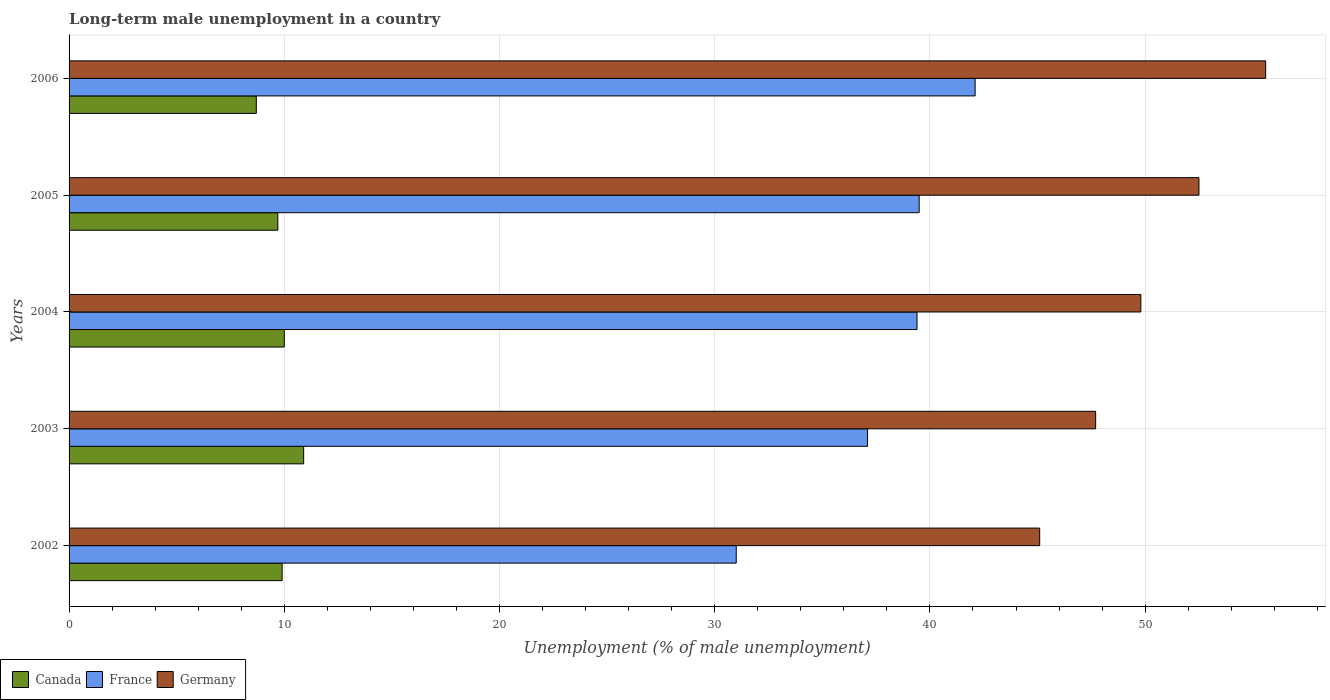How many different coloured bars are there?
Offer a terse response. 3. Are the number of bars per tick equal to the number of legend labels?
Give a very brief answer. Yes. Are the number of bars on each tick of the Y-axis equal?
Offer a very short reply. Yes. What is the percentage of long-term unemployed male population in Canada in 2006?
Offer a terse response. 8.7. Across all years, what is the maximum percentage of long-term unemployed male population in France?
Your response must be concise. 42.1. Across all years, what is the minimum percentage of long-term unemployed male population in Germany?
Offer a terse response. 45.1. In which year was the percentage of long-term unemployed male population in France maximum?
Your answer should be very brief. 2006. In which year was the percentage of long-term unemployed male population in Canada minimum?
Provide a succinct answer. 2006. What is the total percentage of long-term unemployed male population in Canada in the graph?
Offer a terse response. 49.2. What is the difference between the percentage of long-term unemployed male population in Germany in 2002 and that in 2004?
Your answer should be very brief. -4.7. What is the difference between the percentage of long-term unemployed male population in Canada in 2004 and the percentage of long-term unemployed male population in France in 2005?
Offer a very short reply. -29.5. What is the average percentage of long-term unemployed male population in France per year?
Offer a very short reply. 37.82. In the year 2002, what is the difference between the percentage of long-term unemployed male population in France and percentage of long-term unemployed male population in Germany?
Your answer should be very brief. -14.1. What is the ratio of the percentage of long-term unemployed male population in Germany in 2002 to that in 2006?
Provide a succinct answer. 0.81. Is the percentage of long-term unemployed male population in France in 2005 less than that in 2006?
Keep it short and to the point. Yes. Is the difference between the percentage of long-term unemployed male population in France in 2004 and 2005 greater than the difference between the percentage of long-term unemployed male population in Germany in 2004 and 2005?
Keep it short and to the point. Yes. What is the difference between the highest and the second highest percentage of long-term unemployed male population in Germany?
Your answer should be compact. 3.1. What is the difference between the highest and the lowest percentage of long-term unemployed male population in Germany?
Offer a terse response. 10.5. In how many years, is the percentage of long-term unemployed male population in Germany greater than the average percentage of long-term unemployed male population in Germany taken over all years?
Your response must be concise. 2. What does the 1st bar from the bottom in 2002 represents?
Your response must be concise. Canada. How many bars are there?
Make the answer very short. 15. How many years are there in the graph?
Your answer should be compact. 5. What is the difference between two consecutive major ticks on the X-axis?
Your answer should be very brief. 10. Where does the legend appear in the graph?
Give a very brief answer. Bottom left. How many legend labels are there?
Provide a short and direct response. 3. How are the legend labels stacked?
Offer a terse response. Horizontal. What is the title of the graph?
Provide a succinct answer. Long-term male unemployment in a country. What is the label or title of the X-axis?
Offer a very short reply. Unemployment (% of male unemployment). What is the Unemployment (% of male unemployment) in Canada in 2002?
Provide a short and direct response. 9.9. What is the Unemployment (% of male unemployment) in Germany in 2002?
Your answer should be very brief. 45.1. What is the Unemployment (% of male unemployment) of Canada in 2003?
Make the answer very short. 10.9. What is the Unemployment (% of male unemployment) in France in 2003?
Give a very brief answer. 37.1. What is the Unemployment (% of male unemployment) in Germany in 2003?
Ensure brevity in your answer.  47.7. What is the Unemployment (% of male unemployment) of Canada in 2004?
Offer a very short reply. 10. What is the Unemployment (% of male unemployment) of France in 2004?
Your answer should be very brief. 39.4. What is the Unemployment (% of male unemployment) in Germany in 2004?
Give a very brief answer. 49.8. What is the Unemployment (% of male unemployment) of Canada in 2005?
Provide a succinct answer. 9.7. What is the Unemployment (% of male unemployment) in France in 2005?
Your answer should be very brief. 39.5. What is the Unemployment (% of male unemployment) in Germany in 2005?
Ensure brevity in your answer.  52.5. What is the Unemployment (% of male unemployment) of Canada in 2006?
Make the answer very short. 8.7. What is the Unemployment (% of male unemployment) of France in 2006?
Make the answer very short. 42.1. What is the Unemployment (% of male unemployment) in Germany in 2006?
Offer a terse response. 55.6. Across all years, what is the maximum Unemployment (% of male unemployment) of Canada?
Keep it short and to the point. 10.9. Across all years, what is the maximum Unemployment (% of male unemployment) in France?
Make the answer very short. 42.1. Across all years, what is the maximum Unemployment (% of male unemployment) of Germany?
Offer a very short reply. 55.6. Across all years, what is the minimum Unemployment (% of male unemployment) in Canada?
Offer a very short reply. 8.7. Across all years, what is the minimum Unemployment (% of male unemployment) of France?
Your answer should be compact. 31. Across all years, what is the minimum Unemployment (% of male unemployment) in Germany?
Your answer should be very brief. 45.1. What is the total Unemployment (% of male unemployment) in Canada in the graph?
Your answer should be compact. 49.2. What is the total Unemployment (% of male unemployment) in France in the graph?
Your answer should be very brief. 189.1. What is the total Unemployment (% of male unemployment) of Germany in the graph?
Keep it short and to the point. 250.7. What is the difference between the Unemployment (% of male unemployment) of Canada in 2002 and that in 2003?
Your answer should be compact. -1. What is the difference between the Unemployment (% of male unemployment) in France in 2002 and that in 2003?
Your answer should be very brief. -6.1. What is the difference between the Unemployment (% of male unemployment) in Germany in 2002 and that in 2003?
Offer a terse response. -2.6. What is the difference between the Unemployment (% of male unemployment) in Germany in 2002 and that in 2004?
Offer a terse response. -4.7. What is the difference between the Unemployment (% of male unemployment) of France in 2002 and that in 2005?
Provide a succinct answer. -8.5. What is the difference between the Unemployment (% of male unemployment) of Germany in 2002 and that in 2005?
Provide a short and direct response. -7.4. What is the difference between the Unemployment (% of male unemployment) of Canada in 2002 and that in 2006?
Provide a short and direct response. 1.2. What is the difference between the Unemployment (% of male unemployment) in France in 2002 and that in 2006?
Ensure brevity in your answer.  -11.1. What is the difference between the Unemployment (% of male unemployment) in Germany in 2002 and that in 2006?
Your response must be concise. -10.5. What is the difference between the Unemployment (% of male unemployment) of Canada in 2003 and that in 2004?
Offer a terse response. 0.9. What is the difference between the Unemployment (% of male unemployment) in France in 2003 and that in 2004?
Provide a short and direct response. -2.3. What is the difference between the Unemployment (% of male unemployment) in France in 2003 and that in 2005?
Provide a short and direct response. -2.4. What is the difference between the Unemployment (% of male unemployment) of Canada in 2003 and that in 2006?
Your answer should be very brief. 2.2. What is the difference between the Unemployment (% of male unemployment) of Germany in 2003 and that in 2006?
Your answer should be compact. -7.9. What is the difference between the Unemployment (% of male unemployment) of France in 2004 and that in 2005?
Provide a succinct answer. -0.1. What is the difference between the Unemployment (% of male unemployment) of Germany in 2004 and that in 2005?
Provide a succinct answer. -2.7. What is the difference between the Unemployment (% of male unemployment) in Canada in 2004 and that in 2006?
Your answer should be compact. 1.3. What is the difference between the Unemployment (% of male unemployment) of France in 2004 and that in 2006?
Provide a succinct answer. -2.7. What is the difference between the Unemployment (% of male unemployment) in Germany in 2004 and that in 2006?
Make the answer very short. -5.8. What is the difference between the Unemployment (% of male unemployment) of France in 2005 and that in 2006?
Make the answer very short. -2.6. What is the difference between the Unemployment (% of male unemployment) of Canada in 2002 and the Unemployment (% of male unemployment) of France in 2003?
Your response must be concise. -27.2. What is the difference between the Unemployment (% of male unemployment) of Canada in 2002 and the Unemployment (% of male unemployment) of Germany in 2003?
Provide a short and direct response. -37.8. What is the difference between the Unemployment (% of male unemployment) of France in 2002 and the Unemployment (% of male unemployment) of Germany in 2003?
Offer a very short reply. -16.7. What is the difference between the Unemployment (% of male unemployment) of Canada in 2002 and the Unemployment (% of male unemployment) of France in 2004?
Your response must be concise. -29.5. What is the difference between the Unemployment (% of male unemployment) in Canada in 2002 and the Unemployment (% of male unemployment) in Germany in 2004?
Make the answer very short. -39.9. What is the difference between the Unemployment (% of male unemployment) of France in 2002 and the Unemployment (% of male unemployment) of Germany in 2004?
Your response must be concise. -18.8. What is the difference between the Unemployment (% of male unemployment) in Canada in 2002 and the Unemployment (% of male unemployment) in France in 2005?
Make the answer very short. -29.6. What is the difference between the Unemployment (% of male unemployment) in Canada in 2002 and the Unemployment (% of male unemployment) in Germany in 2005?
Your response must be concise. -42.6. What is the difference between the Unemployment (% of male unemployment) in France in 2002 and the Unemployment (% of male unemployment) in Germany in 2005?
Give a very brief answer. -21.5. What is the difference between the Unemployment (% of male unemployment) of Canada in 2002 and the Unemployment (% of male unemployment) of France in 2006?
Your answer should be very brief. -32.2. What is the difference between the Unemployment (% of male unemployment) of Canada in 2002 and the Unemployment (% of male unemployment) of Germany in 2006?
Provide a succinct answer. -45.7. What is the difference between the Unemployment (% of male unemployment) in France in 2002 and the Unemployment (% of male unemployment) in Germany in 2006?
Your response must be concise. -24.6. What is the difference between the Unemployment (% of male unemployment) of Canada in 2003 and the Unemployment (% of male unemployment) of France in 2004?
Your response must be concise. -28.5. What is the difference between the Unemployment (% of male unemployment) of Canada in 2003 and the Unemployment (% of male unemployment) of Germany in 2004?
Your answer should be compact. -38.9. What is the difference between the Unemployment (% of male unemployment) of France in 2003 and the Unemployment (% of male unemployment) of Germany in 2004?
Provide a short and direct response. -12.7. What is the difference between the Unemployment (% of male unemployment) in Canada in 2003 and the Unemployment (% of male unemployment) in France in 2005?
Make the answer very short. -28.6. What is the difference between the Unemployment (% of male unemployment) of Canada in 2003 and the Unemployment (% of male unemployment) of Germany in 2005?
Provide a short and direct response. -41.6. What is the difference between the Unemployment (% of male unemployment) in France in 2003 and the Unemployment (% of male unemployment) in Germany in 2005?
Your answer should be compact. -15.4. What is the difference between the Unemployment (% of male unemployment) of Canada in 2003 and the Unemployment (% of male unemployment) of France in 2006?
Give a very brief answer. -31.2. What is the difference between the Unemployment (% of male unemployment) of Canada in 2003 and the Unemployment (% of male unemployment) of Germany in 2006?
Keep it short and to the point. -44.7. What is the difference between the Unemployment (% of male unemployment) of France in 2003 and the Unemployment (% of male unemployment) of Germany in 2006?
Make the answer very short. -18.5. What is the difference between the Unemployment (% of male unemployment) of Canada in 2004 and the Unemployment (% of male unemployment) of France in 2005?
Ensure brevity in your answer.  -29.5. What is the difference between the Unemployment (% of male unemployment) of Canada in 2004 and the Unemployment (% of male unemployment) of Germany in 2005?
Give a very brief answer. -42.5. What is the difference between the Unemployment (% of male unemployment) in Canada in 2004 and the Unemployment (% of male unemployment) in France in 2006?
Ensure brevity in your answer.  -32.1. What is the difference between the Unemployment (% of male unemployment) of Canada in 2004 and the Unemployment (% of male unemployment) of Germany in 2006?
Provide a succinct answer. -45.6. What is the difference between the Unemployment (% of male unemployment) of France in 2004 and the Unemployment (% of male unemployment) of Germany in 2006?
Your answer should be compact. -16.2. What is the difference between the Unemployment (% of male unemployment) in Canada in 2005 and the Unemployment (% of male unemployment) in France in 2006?
Provide a succinct answer. -32.4. What is the difference between the Unemployment (% of male unemployment) of Canada in 2005 and the Unemployment (% of male unemployment) of Germany in 2006?
Your response must be concise. -45.9. What is the difference between the Unemployment (% of male unemployment) in France in 2005 and the Unemployment (% of male unemployment) in Germany in 2006?
Your answer should be compact. -16.1. What is the average Unemployment (% of male unemployment) in Canada per year?
Offer a terse response. 9.84. What is the average Unemployment (% of male unemployment) of France per year?
Offer a very short reply. 37.82. What is the average Unemployment (% of male unemployment) of Germany per year?
Give a very brief answer. 50.14. In the year 2002, what is the difference between the Unemployment (% of male unemployment) in Canada and Unemployment (% of male unemployment) in France?
Offer a very short reply. -21.1. In the year 2002, what is the difference between the Unemployment (% of male unemployment) of Canada and Unemployment (% of male unemployment) of Germany?
Provide a succinct answer. -35.2. In the year 2002, what is the difference between the Unemployment (% of male unemployment) of France and Unemployment (% of male unemployment) of Germany?
Your answer should be very brief. -14.1. In the year 2003, what is the difference between the Unemployment (% of male unemployment) of Canada and Unemployment (% of male unemployment) of France?
Your answer should be very brief. -26.2. In the year 2003, what is the difference between the Unemployment (% of male unemployment) of Canada and Unemployment (% of male unemployment) of Germany?
Provide a succinct answer. -36.8. In the year 2003, what is the difference between the Unemployment (% of male unemployment) of France and Unemployment (% of male unemployment) of Germany?
Give a very brief answer. -10.6. In the year 2004, what is the difference between the Unemployment (% of male unemployment) in Canada and Unemployment (% of male unemployment) in France?
Your answer should be compact. -29.4. In the year 2004, what is the difference between the Unemployment (% of male unemployment) of Canada and Unemployment (% of male unemployment) of Germany?
Ensure brevity in your answer.  -39.8. In the year 2004, what is the difference between the Unemployment (% of male unemployment) in France and Unemployment (% of male unemployment) in Germany?
Ensure brevity in your answer.  -10.4. In the year 2005, what is the difference between the Unemployment (% of male unemployment) in Canada and Unemployment (% of male unemployment) in France?
Your answer should be compact. -29.8. In the year 2005, what is the difference between the Unemployment (% of male unemployment) of Canada and Unemployment (% of male unemployment) of Germany?
Make the answer very short. -42.8. In the year 2006, what is the difference between the Unemployment (% of male unemployment) of Canada and Unemployment (% of male unemployment) of France?
Ensure brevity in your answer.  -33.4. In the year 2006, what is the difference between the Unemployment (% of male unemployment) in Canada and Unemployment (% of male unemployment) in Germany?
Make the answer very short. -46.9. In the year 2006, what is the difference between the Unemployment (% of male unemployment) of France and Unemployment (% of male unemployment) of Germany?
Offer a terse response. -13.5. What is the ratio of the Unemployment (% of male unemployment) of Canada in 2002 to that in 2003?
Give a very brief answer. 0.91. What is the ratio of the Unemployment (% of male unemployment) of France in 2002 to that in 2003?
Give a very brief answer. 0.84. What is the ratio of the Unemployment (% of male unemployment) in Germany in 2002 to that in 2003?
Your answer should be compact. 0.95. What is the ratio of the Unemployment (% of male unemployment) of Canada in 2002 to that in 2004?
Your response must be concise. 0.99. What is the ratio of the Unemployment (% of male unemployment) of France in 2002 to that in 2004?
Make the answer very short. 0.79. What is the ratio of the Unemployment (% of male unemployment) in Germany in 2002 to that in 2004?
Your answer should be compact. 0.91. What is the ratio of the Unemployment (% of male unemployment) of Canada in 2002 to that in 2005?
Keep it short and to the point. 1.02. What is the ratio of the Unemployment (% of male unemployment) in France in 2002 to that in 2005?
Make the answer very short. 0.78. What is the ratio of the Unemployment (% of male unemployment) in Germany in 2002 to that in 2005?
Give a very brief answer. 0.86. What is the ratio of the Unemployment (% of male unemployment) of Canada in 2002 to that in 2006?
Ensure brevity in your answer.  1.14. What is the ratio of the Unemployment (% of male unemployment) of France in 2002 to that in 2006?
Offer a very short reply. 0.74. What is the ratio of the Unemployment (% of male unemployment) of Germany in 2002 to that in 2006?
Offer a very short reply. 0.81. What is the ratio of the Unemployment (% of male unemployment) of Canada in 2003 to that in 2004?
Provide a succinct answer. 1.09. What is the ratio of the Unemployment (% of male unemployment) of France in 2003 to that in 2004?
Give a very brief answer. 0.94. What is the ratio of the Unemployment (% of male unemployment) in Germany in 2003 to that in 2004?
Offer a terse response. 0.96. What is the ratio of the Unemployment (% of male unemployment) of Canada in 2003 to that in 2005?
Give a very brief answer. 1.12. What is the ratio of the Unemployment (% of male unemployment) of France in 2003 to that in 2005?
Give a very brief answer. 0.94. What is the ratio of the Unemployment (% of male unemployment) in Germany in 2003 to that in 2005?
Offer a terse response. 0.91. What is the ratio of the Unemployment (% of male unemployment) of Canada in 2003 to that in 2006?
Offer a very short reply. 1.25. What is the ratio of the Unemployment (% of male unemployment) in France in 2003 to that in 2006?
Provide a short and direct response. 0.88. What is the ratio of the Unemployment (% of male unemployment) of Germany in 2003 to that in 2006?
Your answer should be very brief. 0.86. What is the ratio of the Unemployment (% of male unemployment) in Canada in 2004 to that in 2005?
Your response must be concise. 1.03. What is the ratio of the Unemployment (% of male unemployment) in France in 2004 to that in 2005?
Your answer should be compact. 1. What is the ratio of the Unemployment (% of male unemployment) in Germany in 2004 to that in 2005?
Offer a terse response. 0.95. What is the ratio of the Unemployment (% of male unemployment) of Canada in 2004 to that in 2006?
Provide a succinct answer. 1.15. What is the ratio of the Unemployment (% of male unemployment) in France in 2004 to that in 2006?
Your response must be concise. 0.94. What is the ratio of the Unemployment (% of male unemployment) in Germany in 2004 to that in 2006?
Ensure brevity in your answer.  0.9. What is the ratio of the Unemployment (% of male unemployment) of Canada in 2005 to that in 2006?
Offer a very short reply. 1.11. What is the ratio of the Unemployment (% of male unemployment) in France in 2005 to that in 2006?
Your response must be concise. 0.94. What is the ratio of the Unemployment (% of male unemployment) of Germany in 2005 to that in 2006?
Provide a succinct answer. 0.94. What is the difference between the highest and the second highest Unemployment (% of male unemployment) in Canada?
Give a very brief answer. 0.9. What is the difference between the highest and the second highest Unemployment (% of male unemployment) in France?
Ensure brevity in your answer.  2.6. What is the difference between the highest and the second highest Unemployment (% of male unemployment) in Germany?
Make the answer very short. 3.1. 